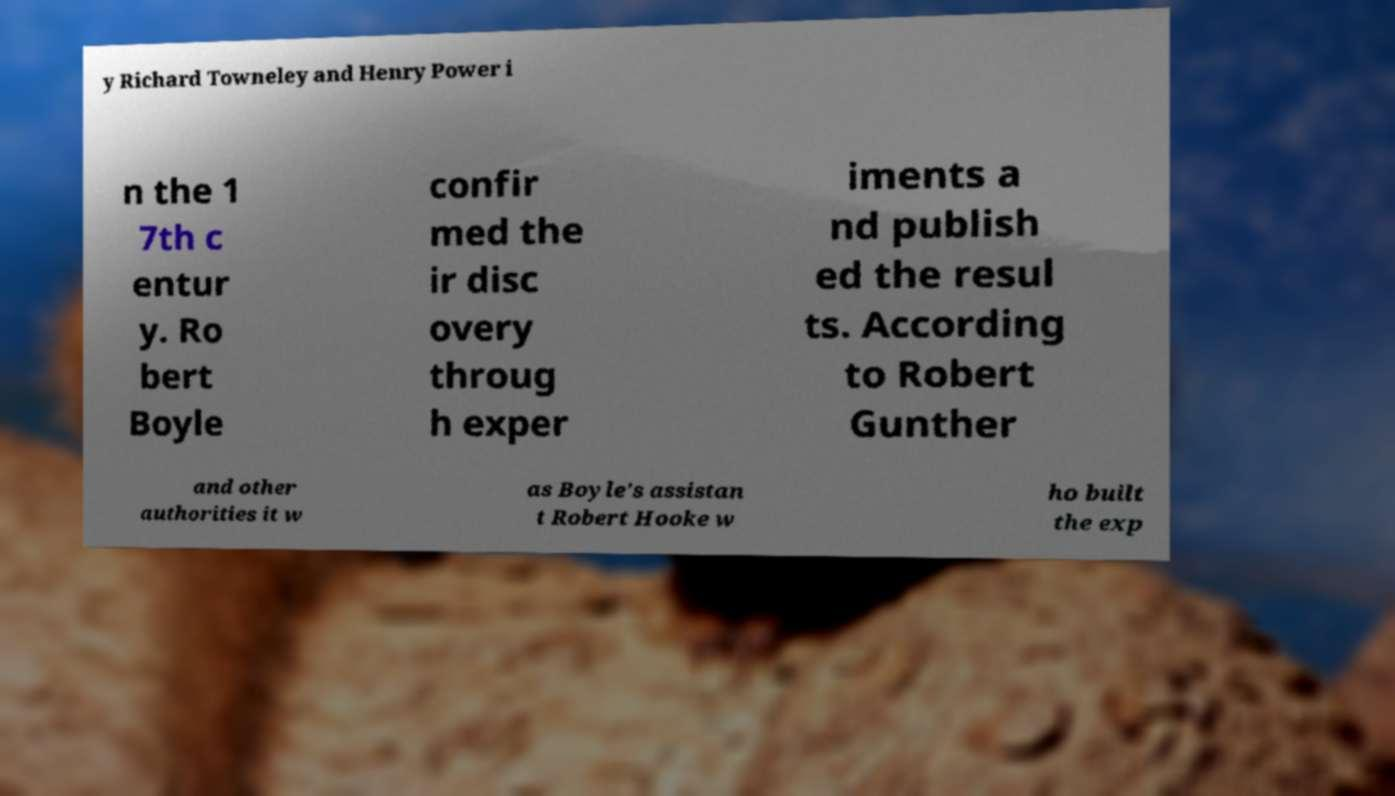Please read and relay the text visible in this image. What does it say? y Richard Towneley and Henry Power i n the 1 7th c entur y. Ro bert Boyle confir med the ir disc overy throug h exper iments a nd publish ed the resul ts. According to Robert Gunther and other authorities it w as Boyle's assistan t Robert Hooke w ho built the exp 